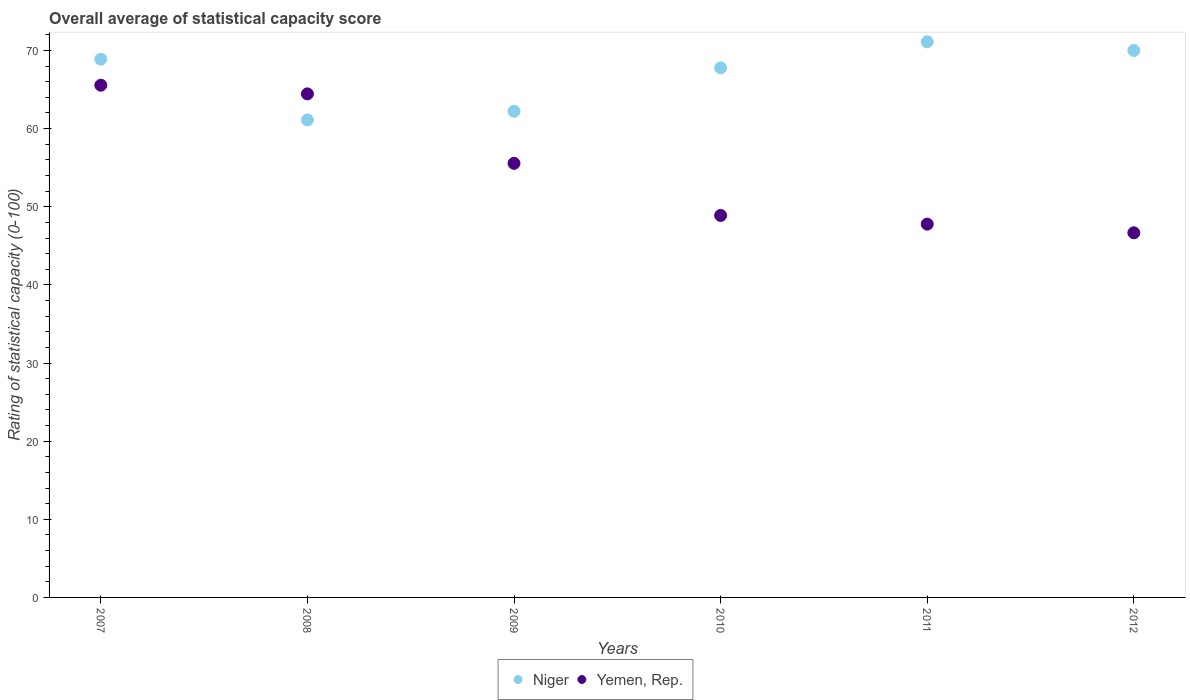Is the number of dotlines equal to the number of legend labels?
Your response must be concise. Yes. What is the rating of statistical capacity in Yemen, Rep. in 2007?
Ensure brevity in your answer.  65.56. Across all years, what is the maximum rating of statistical capacity in Yemen, Rep.?
Ensure brevity in your answer.  65.56. Across all years, what is the minimum rating of statistical capacity in Yemen, Rep.?
Your response must be concise. 46.67. In which year was the rating of statistical capacity in Yemen, Rep. maximum?
Your answer should be compact. 2007. In which year was the rating of statistical capacity in Niger minimum?
Provide a succinct answer. 2008. What is the total rating of statistical capacity in Niger in the graph?
Your response must be concise. 401.11. What is the difference between the rating of statistical capacity in Niger in 2009 and that in 2012?
Make the answer very short. -7.78. What is the difference between the rating of statistical capacity in Niger in 2010 and the rating of statistical capacity in Yemen, Rep. in 2008?
Keep it short and to the point. 3.33. What is the average rating of statistical capacity in Niger per year?
Offer a terse response. 66.85. In the year 2007, what is the difference between the rating of statistical capacity in Niger and rating of statistical capacity in Yemen, Rep.?
Your response must be concise. 3.33. In how many years, is the rating of statistical capacity in Niger greater than 16?
Provide a succinct answer. 6. What is the ratio of the rating of statistical capacity in Yemen, Rep. in 2007 to that in 2008?
Your answer should be compact. 1.02. Is the difference between the rating of statistical capacity in Niger in 2007 and 2008 greater than the difference between the rating of statistical capacity in Yemen, Rep. in 2007 and 2008?
Offer a very short reply. Yes. What is the difference between the highest and the second highest rating of statistical capacity in Yemen, Rep.?
Give a very brief answer. 1.11. What is the difference between the highest and the lowest rating of statistical capacity in Niger?
Make the answer very short. 10. In how many years, is the rating of statistical capacity in Yemen, Rep. greater than the average rating of statistical capacity in Yemen, Rep. taken over all years?
Offer a terse response. 3. Is the sum of the rating of statistical capacity in Niger in 2008 and 2012 greater than the maximum rating of statistical capacity in Yemen, Rep. across all years?
Offer a very short reply. Yes. Does the rating of statistical capacity in Yemen, Rep. monotonically increase over the years?
Give a very brief answer. No. How many dotlines are there?
Ensure brevity in your answer.  2. Are the values on the major ticks of Y-axis written in scientific E-notation?
Offer a terse response. No. Does the graph contain grids?
Offer a very short reply. No. How many legend labels are there?
Provide a short and direct response. 2. What is the title of the graph?
Offer a very short reply. Overall average of statistical capacity score. Does "Lithuania" appear as one of the legend labels in the graph?
Offer a very short reply. No. What is the label or title of the X-axis?
Your answer should be compact. Years. What is the label or title of the Y-axis?
Provide a short and direct response. Rating of statistical capacity (0-100). What is the Rating of statistical capacity (0-100) in Niger in 2007?
Keep it short and to the point. 68.89. What is the Rating of statistical capacity (0-100) of Yemen, Rep. in 2007?
Your answer should be compact. 65.56. What is the Rating of statistical capacity (0-100) in Niger in 2008?
Ensure brevity in your answer.  61.11. What is the Rating of statistical capacity (0-100) in Yemen, Rep. in 2008?
Offer a very short reply. 64.44. What is the Rating of statistical capacity (0-100) of Niger in 2009?
Your answer should be very brief. 62.22. What is the Rating of statistical capacity (0-100) in Yemen, Rep. in 2009?
Ensure brevity in your answer.  55.56. What is the Rating of statistical capacity (0-100) in Niger in 2010?
Ensure brevity in your answer.  67.78. What is the Rating of statistical capacity (0-100) in Yemen, Rep. in 2010?
Your answer should be compact. 48.89. What is the Rating of statistical capacity (0-100) in Niger in 2011?
Offer a terse response. 71.11. What is the Rating of statistical capacity (0-100) of Yemen, Rep. in 2011?
Your answer should be compact. 47.78. What is the Rating of statistical capacity (0-100) in Niger in 2012?
Make the answer very short. 70. What is the Rating of statistical capacity (0-100) of Yemen, Rep. in 2012?
Your answer should be compact. 46.67. Across all years, what is the maximum Rating of statistical capacity (0-100) in Niger?
Make the answer very short. 71.11. Across all years, what is the maximum Rating of statistical capacity (0-100) in Yemen, Rep.?
Ensure brevity in your answer.  65.56. Across all years, what is the minimum Rating of statistical capacity (0-100) in Niger?
Offer a very short reply. 61.11. Across all years, what is the minimum Rating of statistical capacity (0-100) in Yemen, Rep.?
Keep it short and to the point. 46.67. What is the total Rating of statistical capacity (0-100) in Niger in the graph?
Your response must be concise. 401.11. What is the total Rating of statistical capacity (0-100) of Yemen, Rep. in the graph?
Your answer should be very brief. 328.89. What is the difference between the Rating of statistical capacity (0-100) in Niger in 2007 and that in 2008?
Ensure brevity in your answer.  7.78. What is the difference between the Rating of statistical capacity (0-100) in Niger in 2007 and that in 2009?
Keep it short and to the point. 6.67. What is the difference between the Rating of statistical capacity (0-100) in Yemen, Rep. in 2007 and that in 2009?
Offer a very short reply. 10. What is the difference between the Rating of statistical capacity (0-100) of Niger in 2007 and that in 2010?
Your answer should be very brief. 1.11. What is the difference between the Rating of statistical capacity (0-100) of Yemen, Rep. in 2007 and that in 2010?
Offer a terse response. 16.67. What is the difference between the Rating of statistical capacity (0-100) in Niger in 2007 and that in 2011?
Ensure brevity in your answer.  -2.22. What is the difference between the Rating of statistical capacity (0-100) in Yemen, Rep. in 2007 and that in 2011?
Your answer should be very brief. 17.78. What is the difference between the Rating of statistical capacity (0-100) in Niger in 2007 and that in 2012?
Provide a short and direct response. -1.11. What is the difference between the Rating of statistical capacity (0-100) in Yemen, Rep. in 2007 and that in 2012?
Your response must be concise. 18.89. What is the difference between the Rating of statistical capacity (0-100) of Niger in 2008 and that in 2009?
Make the answer very short. -1.11. What is the difference between the Rating of statistical capacity (0-100) of Yemen, Rep. in 2008 and that in 2009?
Make the answer very short. 8.89. What is the difference between the Rating of statistical capacity (0-100) of Niger in 2008 and that in 2010?
Keep it short and to the point. -6.67. What is the difference between the Rating of statistical capacity (0-100) of Yemen, Rep. in 2008 and that in 2010?
Give a very brief answer. 15.56. What is the difference between the Rating of statistical capacity (0-100) of Niger in 2008 and that in 2011?
Offer a very short reply. -10. What is the difference between the Rating of statistical capacity (0-100) in Yemen, Rep. in 2008 and that in 2011?
Give a very brief answer. 16.67. What is the difference between the Rating of statistical capacity (0-100) in Niger in 2008 and that in 2012?
Give a very brief answer. -8.89. What is the difference between the Rating of statistical capacity (0-100) of Yemen, Rep. in 2008 and that in 2012?
Provide a succinct answer. 17.78. What is the difference between the Rating of statistical capacity (0-100) in Niger in 2009 and that in 2010?
Provide a succinct answer. -5.56. What is the difference between the Rating of statistical capacity (0-100) in Yemen, Rep. in 2009 and that in 2010?
Your answer should be very brief. 6.67. What is the difference between the Rating of statistical capacity (0-100) in Niger in 2009 and that in 2011?
Give a very brief answer. -8.89. What is the difference between the Rating of statistical capacity (0-100) of Yemen, Rep. in 2009 and that in 2011?
Provide a succinct answer. 7.78. What is the difference between the Rating of statistical capacity (0-100) of Niger in 2009 and that in 2012?
Your answer should be very brief. -7.78. What is the difference between the Rating of statistical capacity (0-100) in Yemen, Rep. in 2009 and that in 2012?
Offer a very short reply. 8.89. What is the difference between the Rating of statistical capacity (0-100) of Niger in 2010 and that in 2011?
Offer a terse response. -3.33. What is the difference between the Rating of statistical capacity (0-100) in Yemen, Rep. in 2010 and that in 2011?
Your answer should be very brief. 1.11. What is the difference between the Rating of statistical capacity (0-100) in Niger in 2010 and that in 2012?
Your answer should be very brief. -2.22. What is the difference between the Rating of statistical capacity (0-100) in Yemen, Rep. in 2010 and that in 2012?
Keep it short and to the point. 2.22. What is the difference between the Rating of statistical capacity (0-100) in Niger in 2011 and that in 2012?
Keep it short and to the point. 1.11. What is the difference between the Rating of statistical capacity (0-100) in Niger in 2007 and the Rating of statistical capacity (0-100) in Yemen, Rep. in 2008?
Keep it short and to the point. 4.44. What is the difference between the Rating of statistical capacity (0-100) in Niger in 2007 and the Rating of statistical capacity (0-100) in Yemen, Rep. in 2009?
Keep it short and to the point. 13.33. What is the difference between the Rating of statistical capacity (0-100) of Niger in 2007 and the Rating of statistical capacity (0-100) of Yemen, Rep. in 2010?
Your answer should be compact. 20. What is the difference between the Rating of statistical capacity (0-100) of Niger in 2007 and the Rating of statistical capacity (0-100) of Yemen, Rep. in 2011?
Keep it short and to the point. 21.11. What is the difference between the Rating of statistical capacity (0-100) of Niger in 2007 and the Rating of statistical capacity (0-100) of Yemen, Rep. in 2012?
Your answer should be compact. 22.22. What is the difference between the Rating of statistical capacity (0-100) of Niger in 2008 and the Rating of statistical capacity (0-100) of Yemen, Rep. in 2009?
Offer a terse response. 5.56. What is the difference between the Rating of statistical capacity (0-100) of Niger in 2008 and the Rating of statistical capacity (0-100) of Yemen, Rep. in 2010?
Your response must be concise. 12.22. What is the difference between the Rating of statistical capacity (0-100) of Niger in 2008 and the Rating of statistical capacity (0-100) of Yemen, Rep. in 2011?
Offer a terse response. 13.33. What is the difference between the Rating of statistical capacity (0-100) in Niger in 2008 and the Rating of statistical capacity (0-100) in Yemen, Rep. in 2012?
Keep it short and to the point. 14.44. What is the difference between the Rating of statistical capacity (0-100) in Niger in 2009 and the Rating of statistical capacity (0-100) in Yemen, Rep. in 2010?
Provide a short and direct response. 13.33. What is the difference between the Rating of statistical capacity (0-100) in Niger in 2009 and the Rating of statistical capacity (0-100) in Yemen, Rep. in 2011?
Your answer should be very brief. 14.44. What is the difference between the Rating of statistical capacity (0-100) of Niger in 2009 and the Rating of statistical capacity (0-100) of Yemen, Rep. in 2012?
Offer a very short reply. 15.56. What is the difference between the Rating of statistical capacity (0-100) of Niger in 2010 and the Rating of statistical capacity (0-100) of Yemen, Rep. in 2011?
Keep it short and to the point. 20. What is the difference between the Rating of statistical capacity (0-100) in Niger in 2010 and the Rating of statistical capacity (0-100) in Yemen, Rep. in 2012?
Give a very brief answer. 21.11. What is the difference between the Rating of statistical capacity (0-100) of Niger in 2011 and the Rating of statistical capacity (0-100) of Yemen, Rep. in 2012?
Your answer should be very brief. 24.44. What is the average Rating of statistical capacity (0-100) in Niger per year?
Provide a short and direct response. 66.85. What is the average Rating of statistical capacity (0-100) in Yemen, Rep. per year?
Keep it short and to the point. 54.81. In the year 2008, what is the difference between the Rating of statistical capacity (0-100) of Niger and Rating of statistical capacity (0-100) of Yemen, Rep.?
Offer a very short reply. -3.33. In the year 2010, what is the difference between the Rating of statistical capacity (0-100) in Niger and Rating of statistical capacity (0-100) in Yemen, Rep.?
Ensure brevity in your answer.  18.89. In the year 2011, what is the difference between the Rating of statistical capacity (0-100) of Niger and Rating of statistical capacity (0-100) of Yemen, Rep.?
Ensure brevity in your answer.  23.33. In the year 2012, what is the difference between the Rating of statistical capacity (0-100) in Niger and Rating of statistical capacity (0-100) in Yemen, Rep.?
Offer a very short reply. 23.33. What is the ratio of the Rating of statistical capacity (0-100) in Niger in 2007 to that in 2008?
Give a very brief answer. 1.13. What is the ratio of the Rating of statistical capacity (0-100) in Yemen, Rep. in 2007 to that in 2008?
Your response must be concise. 1.02. What is the ratio of the Rating of statistical capacity (0-100) of Niger in 2007 to that in 2009?
Make the answer very short. 1.11. What is the ratio of the Rating of statistical capacity (0-100) of Yemen, Rep. in 2007 to that in 2009?
Give a very brief answer. 1.18. What is the ratio of the Rating of statistical capacity (0-100) in Niger in 2007 to that in 2010?
Your response must be concise. 1.02. What is the ratio of the Rating of statistical capacity (0-100) of Yemen, Rep. in 2007 to that in 2010?
Keep it short and to the point. 1.34. What is the ratio of the Rating of statistical capacity (0-100) of Niger in 2007 to that in 2011?
Offer a terse response. 0.97. What is the ratio of the Rating of statistical capacity (0-100) in Yemen, Rep. in 2007 to that in 2011?
Your answer should be compact. 1.37. What is the ratio of the Rating of statistical capacity (0-100) in Niger in 2007 to that in 2012?
Your response must be concise. 0.98. What is the ratio of the Rating of statistical capacity (0-100) of Yemen, Rep. in 2007 to that in 2012?
Offer a very short reply. 1.4. What is the ratio of the Rating of statistical capacity (0-100) in Niger in 2008 to that in 2009?
Offer a very short reply. 0.98. What is the ratio of the Rating of statistical capacity (0-100) in Yemen, Rep. in 2008 to that in 2009?
Keep it short and to the point. 1.16. What is the ratio of the Rating of statistical capacity (0-100) in Niger in 2008 to that in 2010?
Your answer should be compact. 0.9. What is the ratio of the Rating of statistical capacity (0-100) of Yemen, Rep. in 2008 to that in 2010?
Provide a succinct answer. 1.32. What is the ratio of the Rating of statistical capacity (0-100) of Niger in 2008 to that in 2011?
Offer a terse response. 0.86. What is the ratio of the Rating of statistical capacity (0-100) of Yemen, Rep. in 2008 to that in 2011?
Give a very brief answer. 1.35. What is the ratio of the Rating of statistical capacity (0-100) in Niger in 2008 to that in 2012?
Ensure brevity in your answer.  0.87. What is the ratio of the Rating of statistical capacity (0-100) in Yemen, Rep. in 2008 to that in 2012?
Offer a terse response. 1.38. What is the ratio of the Rating of statistical capacity (0-100) of Niger in 2009 to that in 2010?
Offer a very short reply. 0.92. What is the ratio of the Rating of statistical capacity (0-100) in Yemen, Rep. in 2009 to that in 2010?
Ensure brevity in your answer.  1.14. What is the ratio of the Rating of statistical capacity (0-100) of Niger in 2009 to that in 2011?
Give a very brief answer. 0.88. What is the ratio of the Rating of statistical capacity (0-100) of Yemen, Rep. in 2009 to that in 2011?
Your answer should be very brief. 1.16. What is the ratio of the Rating of statistical capacity (0-100) of Yemen, Rep. in 2009 to that in 2012?
Make the answer very short. 1.19. What is the ratio of the Rating of statistical capacity (0-100) of Niger in 2010 to that in 2011?
Provide a short and direct response. 0.95. What is the ratio of the Rating of statistical capacity (0-100) of Yemen, Rep. in 2010 to that in 2011?
Keep it short and to the point. 1.02. What is the ratio of the Rating of statistical capacity (0-100) of Niger in 2010 to that in 2012?
Offer a very short reply. 0.97. What is the ratio of the Rating of statistical capacity (0-100) of Yemen, Rep. in 2010 to that in 2012?
Make the answer very short. 1.05. What is the ratio of the Rating of statistical capacity (0-100) of Niger in 2011 to that in 2012?
Your answer should be compact. 1.02. What is the ratio of the Rating of statistical capacity (0-100) in Yemen, Rep. in 2011 to that in 2012?
Provide a succinct answer. 1.02. What is the difference between the highest and the lowest Rating of statistical capacity (0-100) of Yemen, Rep.?
Make the answer very short. 18.89. 